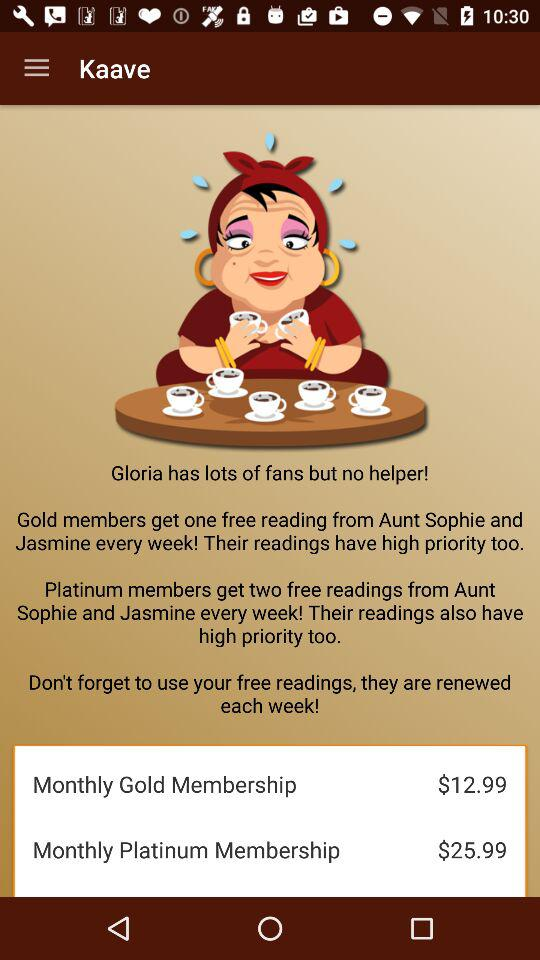How much more does the platinum membership cost compared to the gold membership?
Answer the question using a single word or phrase. $13.00 